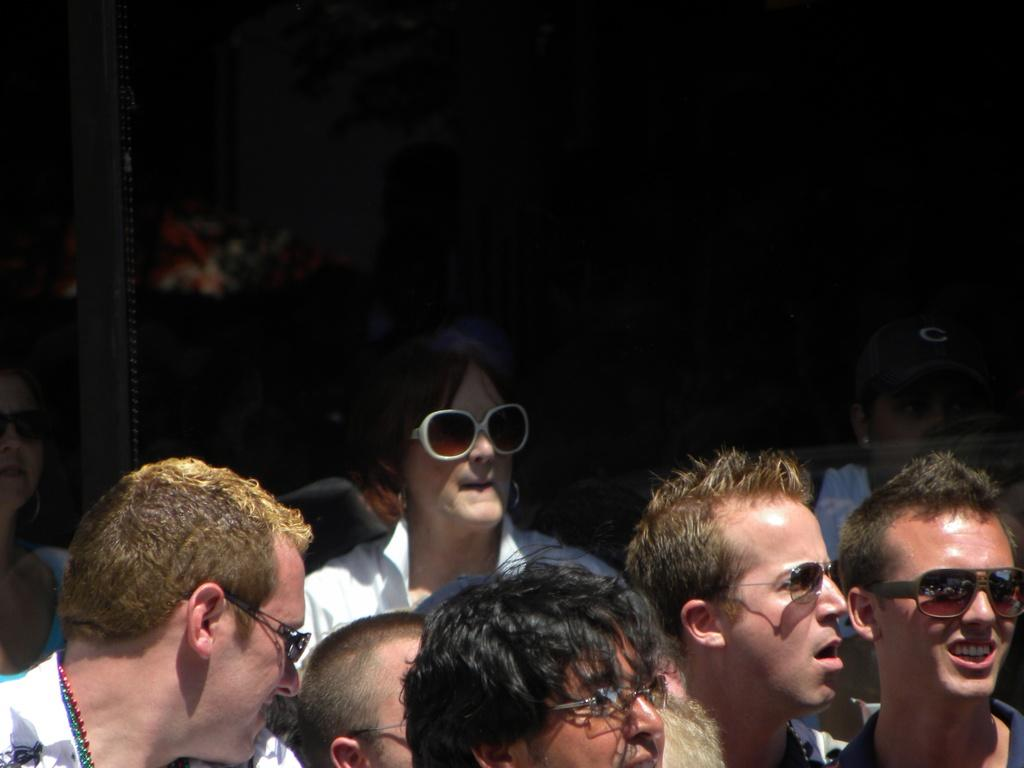How many people are in the image? The number of people in the image cannot be determined from the given fact. What type of channel can be seen in the image? There is no channel present in the image, as the only fact provided is that there are people in the image. 